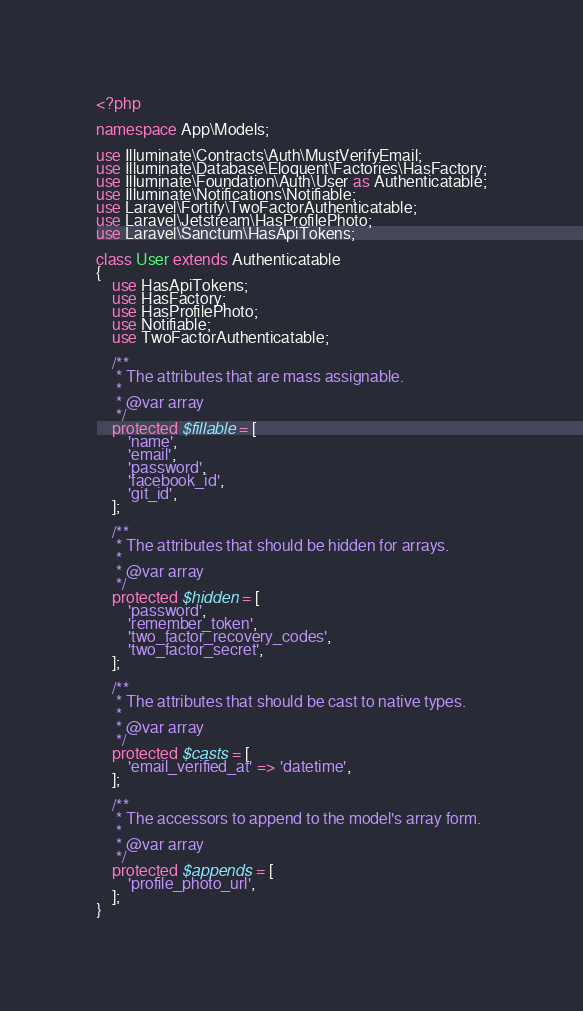<code> <loc_0><loc_0><loc_500><loc_500><_PHP_><?php

namespace App\Models;

use Illuminate\Contracts\Auth\MustVerifyEmail;
use Illuminate\Database\Eloquent\Factories\HasFactory;
use Illuminate\Foundation\Auth\User as Authenticatable;
use Illuminate\Notifications\Notifiable;
use Laravel\Fortify\TwoFactorAuthenticatable;
use Laravel\Jetstream\HasProfilePhoto;
use Laravel\Sanctum\HasApiTokens;

class User extends Authenticatable
{
    use HasApiTokens;
    use HasFactory;
    use HasProfilePhoto;
    use Notifiable;
    use TwoFactorAuthenticatable;

    /**
     * The attributes that are mass assignable.
     *
     * @var array
     */
    protected $fillable = [
        'name',
        'email',
        'password',
        'facebook_id',
        'git_id',
    ];

    /**
     * The attributes that should be hidden for arrays.
     *
     * @var array
     */
    protected $hidden = [
        'password',
        'remember_token',
        'two_factor_recovery_codes',
        'two_factor_secret',
    ];

    /**
     * The attributes that should be cast to native types.
     *
     * @var array
     */
    protected $casts = [
        'email_verified_at' => 'datetime',
    ];

    /**
     * The accessors to append to the model's array form.
     *
     * @var array
     */
    protected $appends = [
        'profile_photo_url',
    ];
}
</code> 